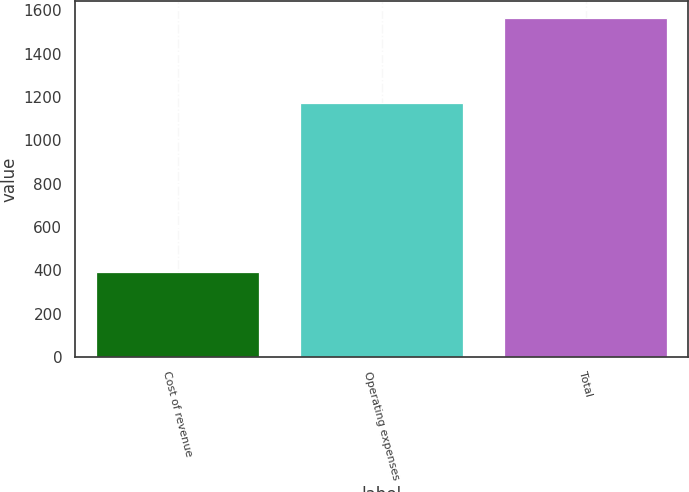Convert chart to OTSL. <chart><loc_0><loc_0><loc_500><loc_500><bar_chart><fcel>Cost of revenue<fcel>Operating expenses<fcel>Total<nl><fcel>392.7<fcel>1173.3<fcel>1566<nl></chart> 